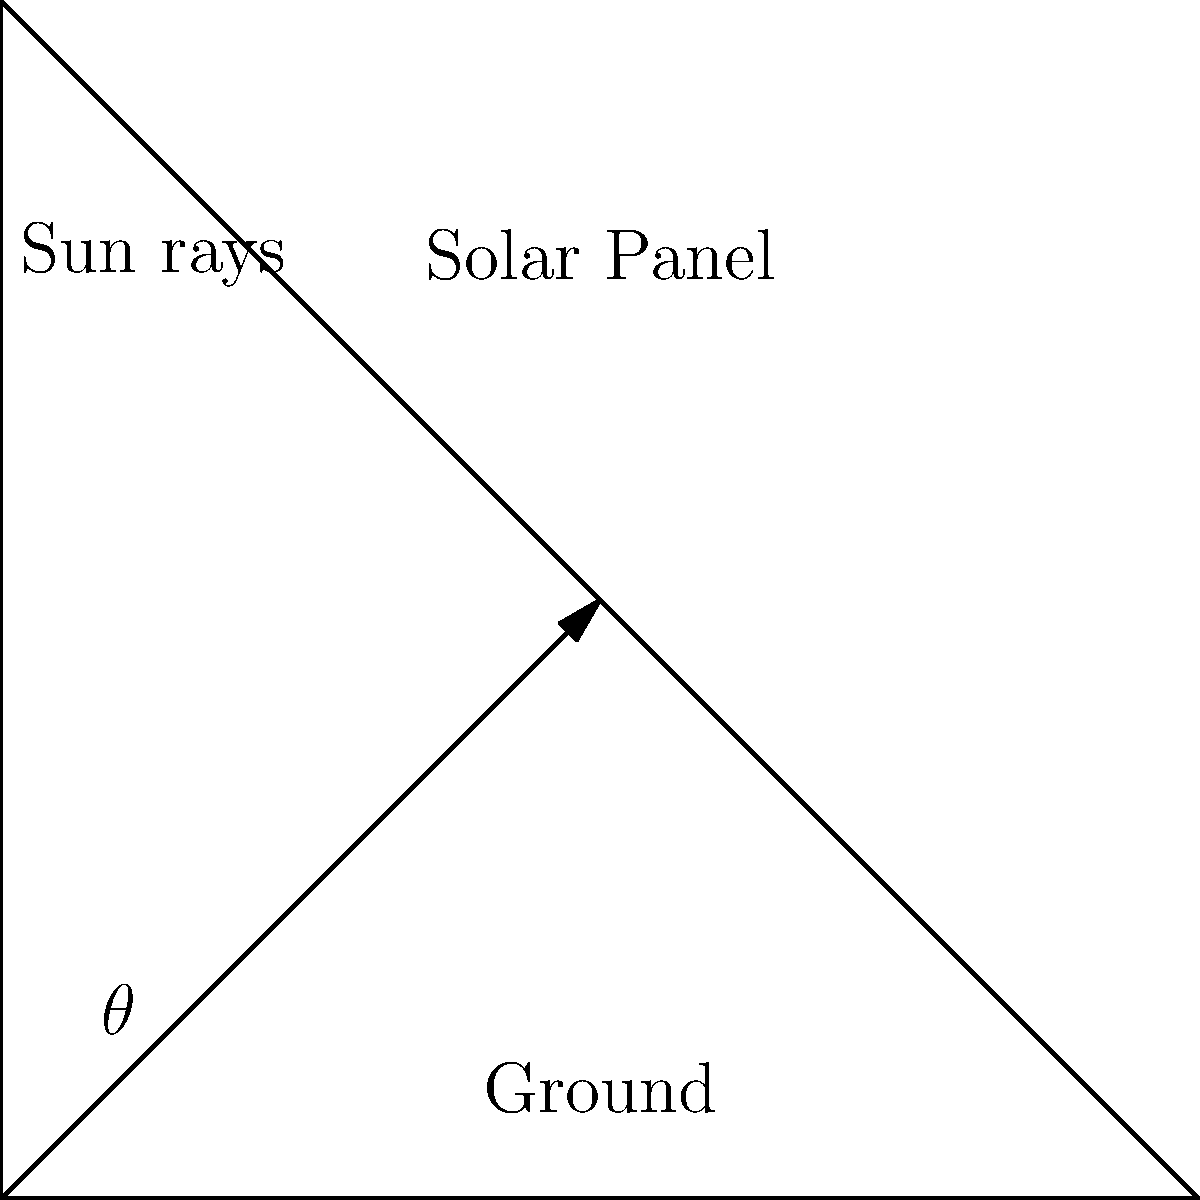A solar panel is installed on a rooftop, and you want to find the optimal angle for maximum energy collection. Given that the sun's position changes throughout the year, what angle $\theta$ (in degrees) should the solar panel be tilted from the horizontal to maximize its annual energy collection if the location's latitude is 40°N? Let's approach this step-by-step:

1) The optimal tilt angle for a solar panel depends on the latitude of the location. A general rule of thumb is that the optimal tilt angle is approximately equal to the latitude of the location.

2) However, this rule is slightly modified to account for seasonal variations and to optimize for annual energy collection.

3) For maximizing annual energy collection, a more precise rule is:
   Optimal tilt angle = (Latitude × 0.76) + 3.1°

4) In this case, the latitude is given as 40°N.

5) Let's plug this into our formula:
   $\theta = (40° × 0.76) + 3.1°$

6) Calculating:
   $\theta = 30.4° + 3.1° = 33.5°$

7) Rounding to the nearest whole number (as most installations don't require decimal precision):
   $\theta ≈ 34°$

This angle provides a balance between summer and winter sun positions, maximizing the annual energy collection. It's a positive outcome that we can find an optimal solution to make the most of a challenging situation!
Answer: $34°$ 